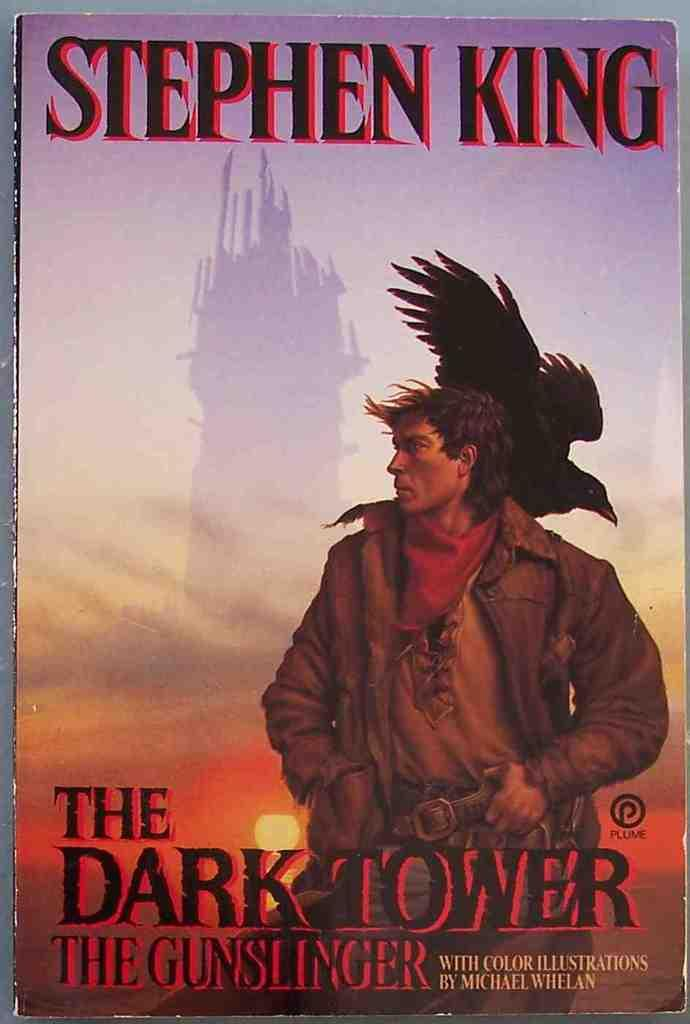<image>
Give a short and clear explanation of the subsequent image. A Stephen King book called The Dark Tower The Gunslinger 